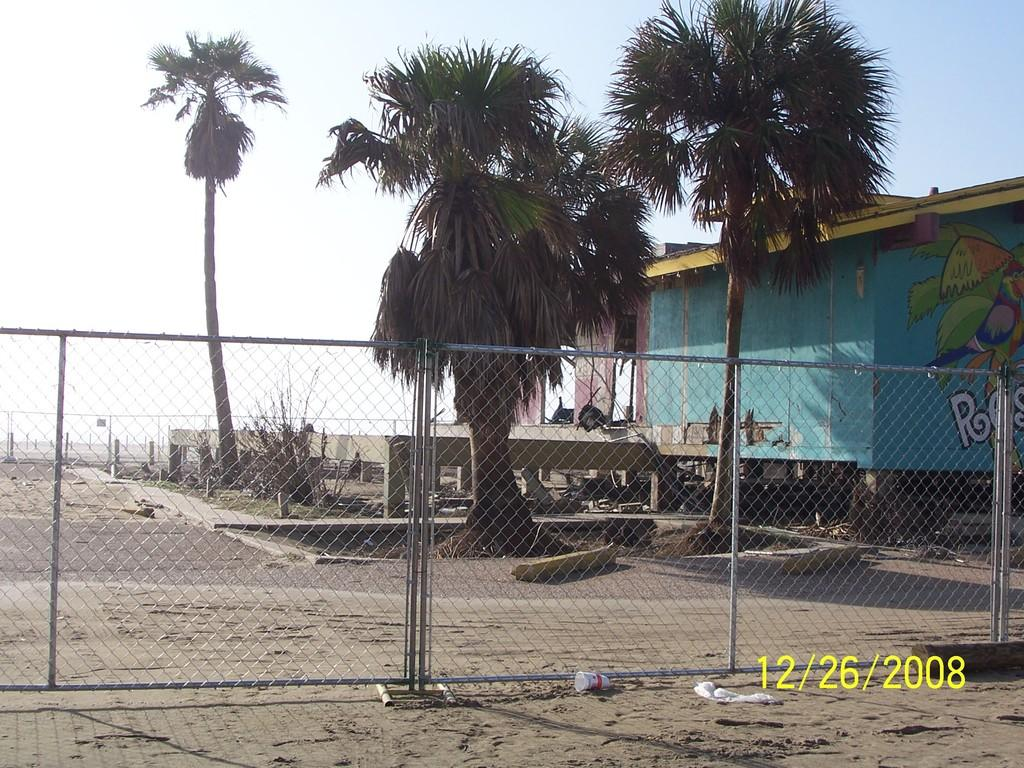What type of vegetation can be seen in the image? There are trees in the image. What structure is located on the right side of the image? There is a shed on the right side of the image. What type of barrier is present in the image? There are fences in the image. What is visible in the background of the image? The sky is visible in the background of the image. How many feet are visible in the image? There are no feet visible in the image. What type of dirt can be seen on the ground in the image? There is no dirt visible in the image; the ground appears to be grass or another type of vegetation. 